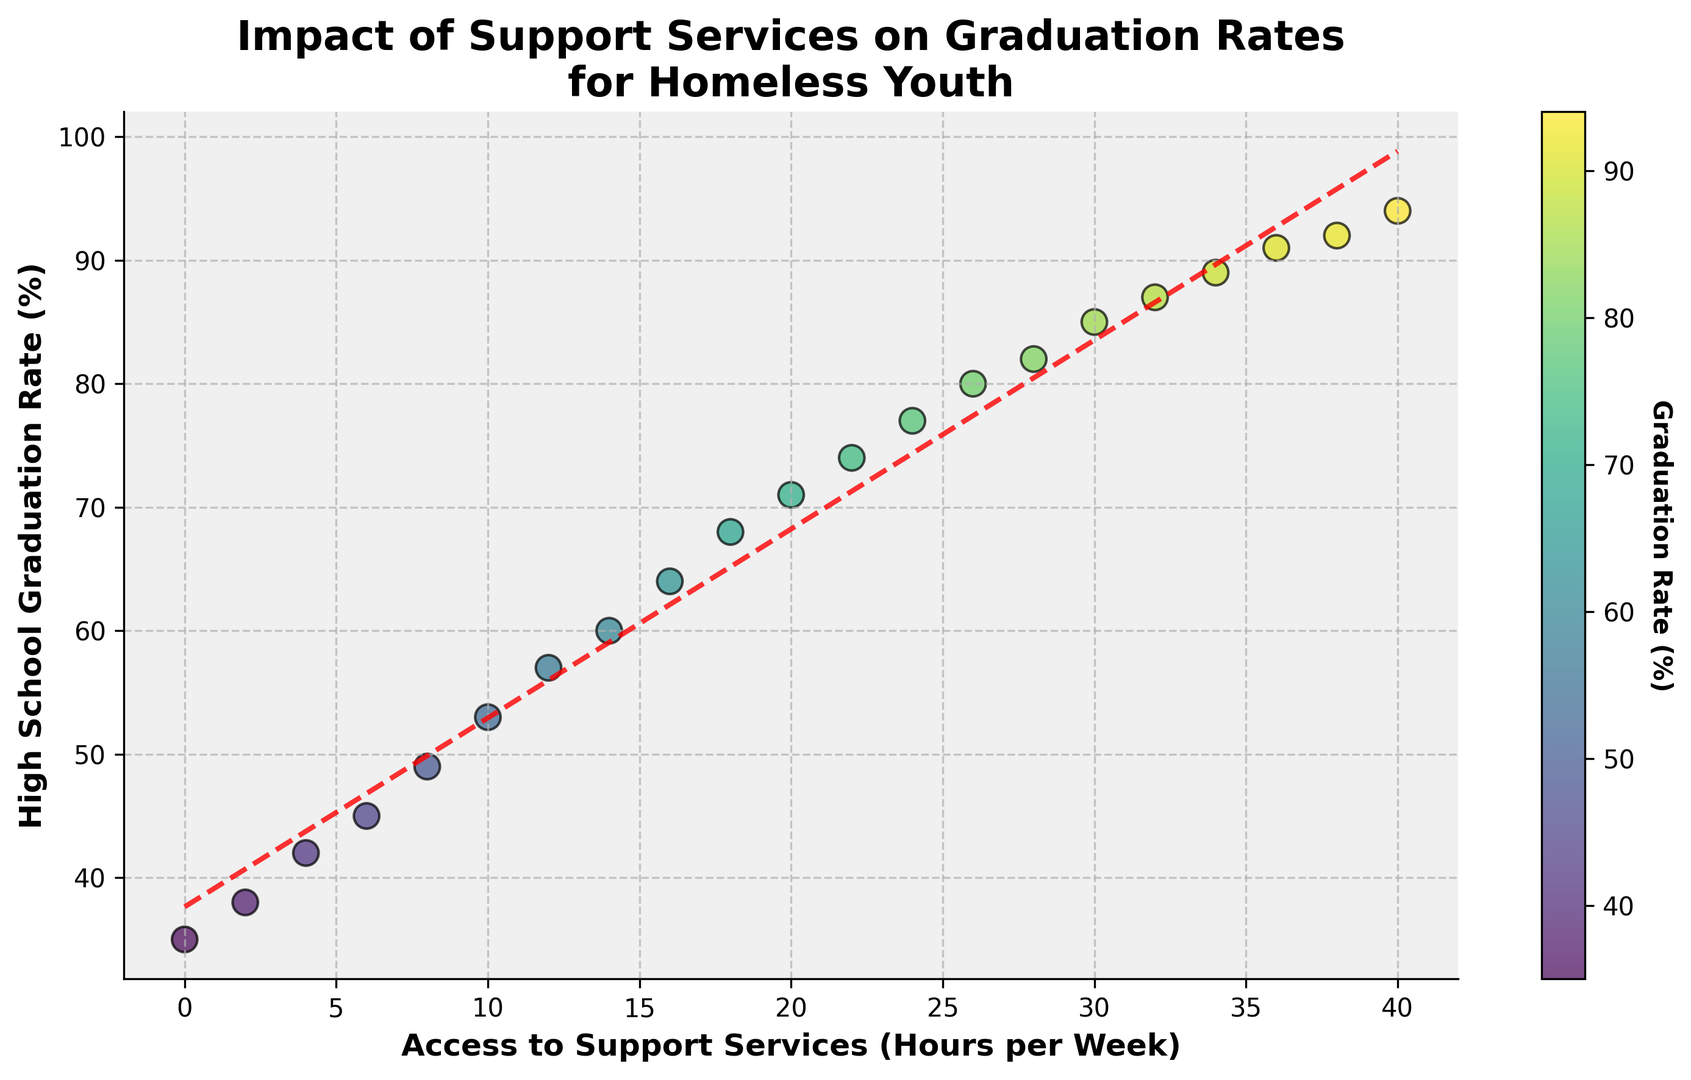What's the minimum graduation rate shown on the plot? The minimum graduation rate shown on the plot is the smallest y-value. Looking at the scatter plot, the minimum y-value is 35%.
Answer: 35% At what number of hours per week of support services is the graduation rate 60%? By referencing the scatter plot, find where the y-value (graduation rate) is 60%. This occurs when the x-value (hours per week) is 14.
Answer: 14 If access to support services increases from 10 to 20 hours per week, how much does the high school graduation rate increase? First, locate the corresponding graduation rates for 10 and 20 hours per week. They are 53% and 71% respectively. Subtract the smaller value from the larger one: 71% - 53% = 18%.
Answer: 18% Is there a general trend between access to support services and high school graduation rates? Observe the overall pattern of the data points. As the hours of access to support services increase, the graduation rate also tends to increase, showing a positive correlation.
Answer: Positive correlation What color represents the highest graduation rates on the plot? Looking at the color bar associated with the scatter plot, the highest graduation rates (90% and above) appear in the color nearest to the "yellow-green" end of the color spectrum.
Answer: Yellow-green At how many hours per week is the graduation rate first seen to be above 80%? Check the plot to see when the y-value first crosses 80%. This occurs at 26 hours per week.
Answer: 26 Estimate the graduation rate if access to support services is 25 hours per week based on the trend line. The trend line can be used to approximate the graduation rate for non-explicit values. For 25 hours per week, the trend line indicates that the graduation rate is approximately 78%.
Answer: 78% Which interval of access to support services per week sees the steepest increase in graduation rates? Analyze the plot to determine where the y-values (graduation rates) rise fastest for changes in x-values (hours per week). Notice the segment between 10 to 20 hours per week, where the increase is particularly rapid.
Answer: 10 to 20 hours per week What is the likely graduation rate when access to support services is 32 hours per week? Find the point on the scatter plot where the x-value is 32. The corresponding y-value is 87%.
Answer: 87% How does the variance in graduation rates change with increasing hours of access to support services? Observe the spread of data points along the x-axis. At lower hours of support services, graduation rates vary widely, but as hours increase, the graduation rates cluster more closely, indicating decreased variance.
Answer: Decreased variance with more hours 